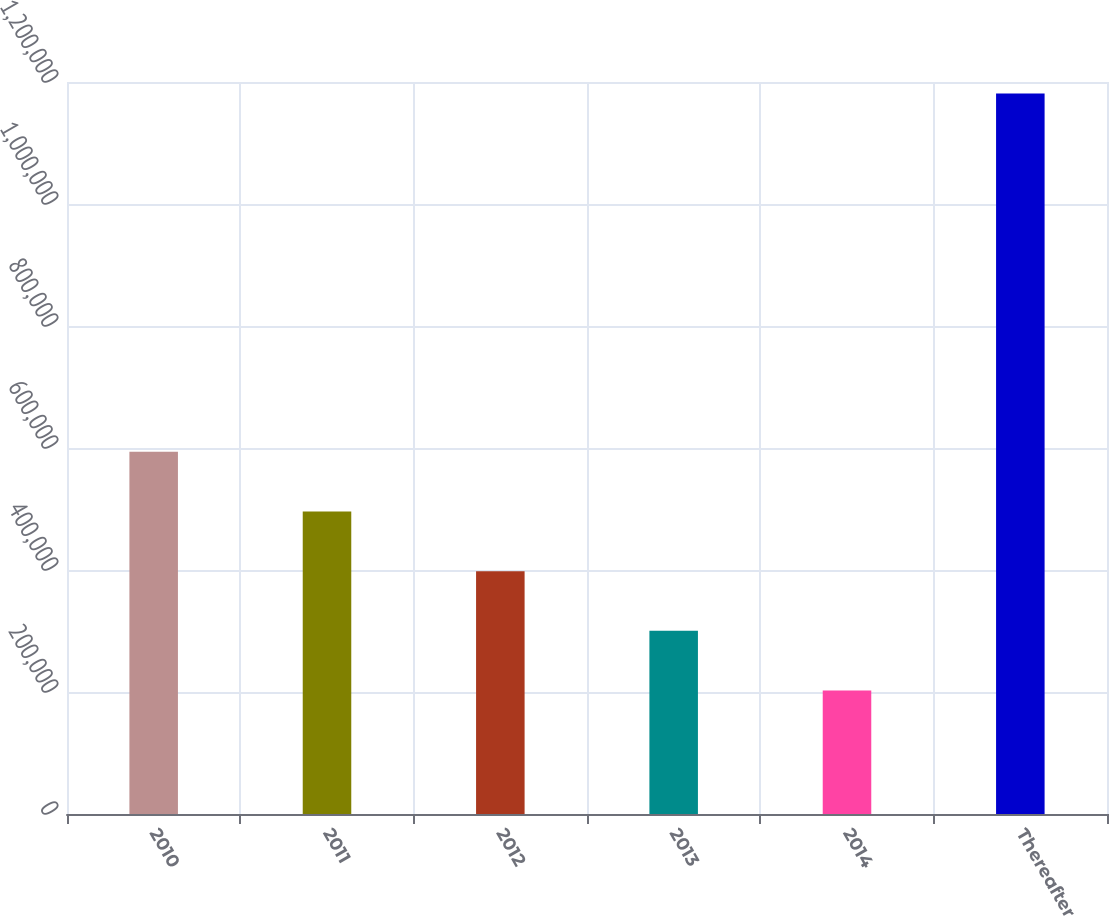<chart> <loc_0><loc_0><loc_500><loc_500><bar_chart><fcel>2010<fcel>2011<fcel>2012<fcel>2013<fcel>2014<fcel>Thereafter<nl><fcel>593823<fcel>495968<fcel>398113<fcel>300258<fcel>202403<fcel>1.18095e+06<nl></chart> 